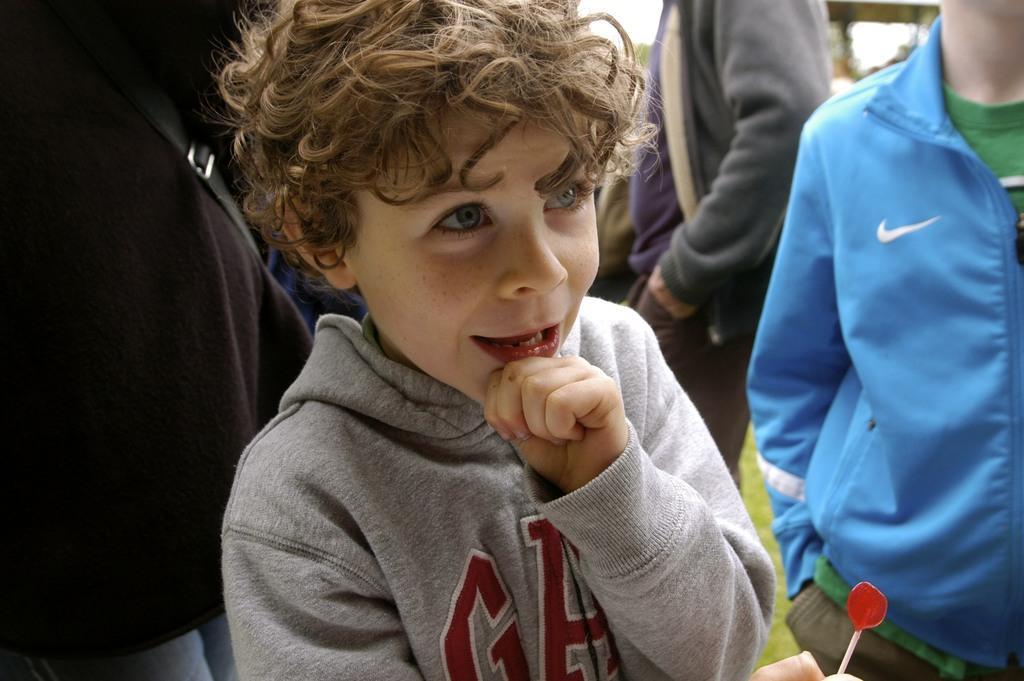Describe this image in one or two sentences. There is a boy holding a candy with stick. In the back there are many people. 